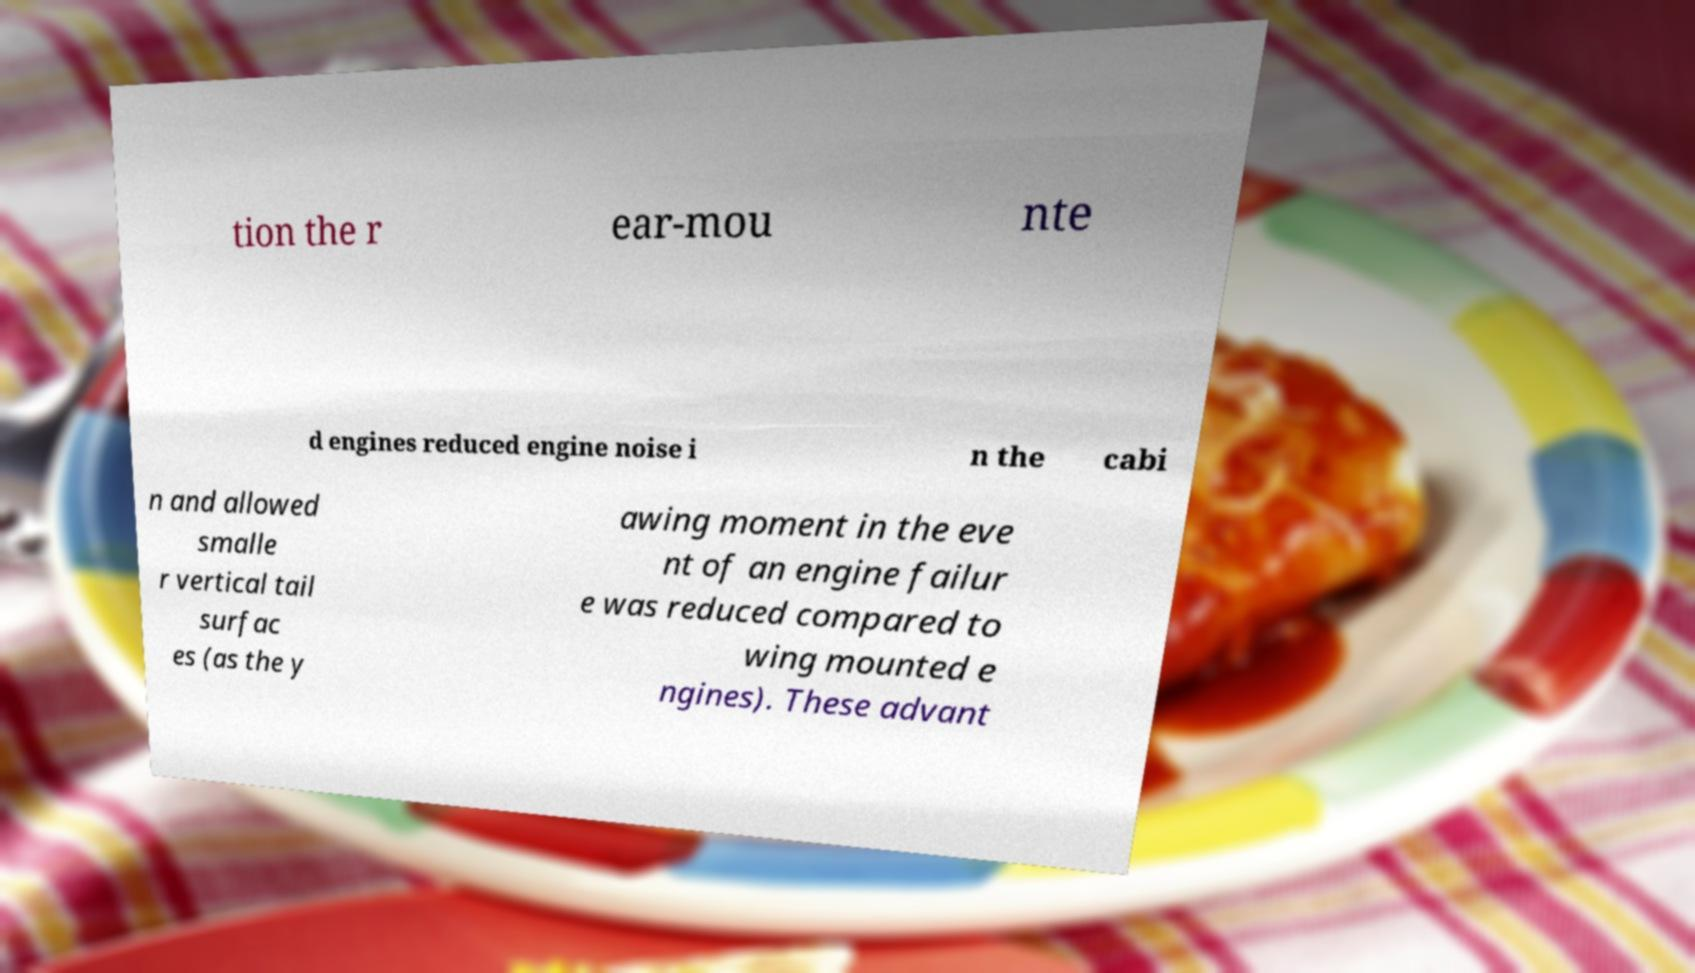Please read and relay the text visible in this image. What does it say? tion the r ear-mou nte d engines reduced engine noise i n the cabi n and allowed smalle r vertical tail surfac es (as the y awing moment in the eve nt of an engine failur e was reduced compared to wing mounted e ngines). These advant 